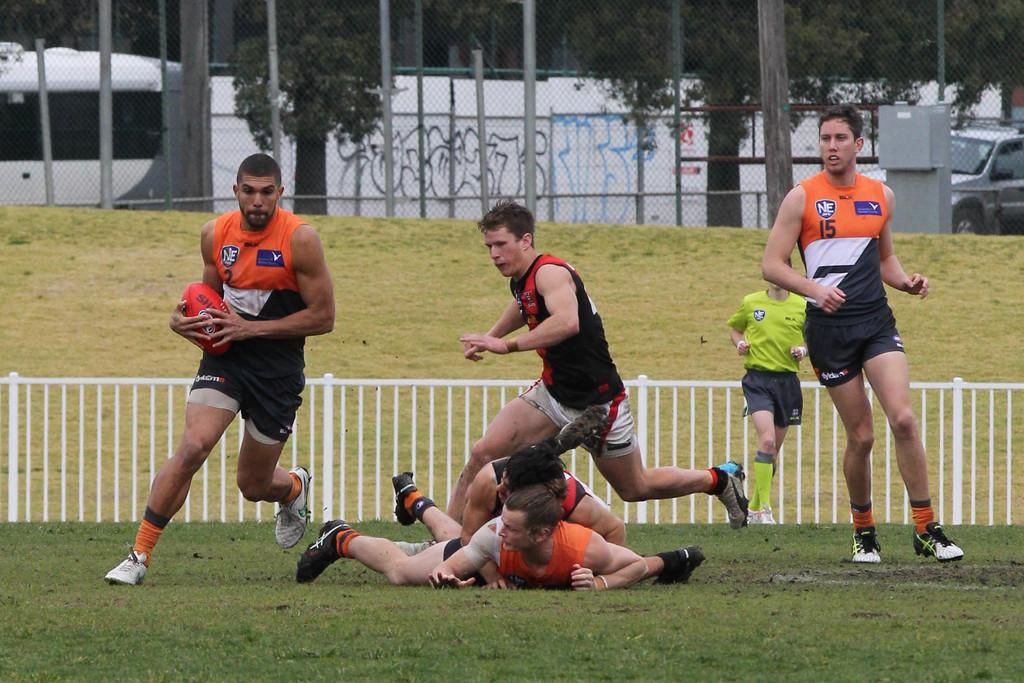<image>
Describe the image concisely. men playing a sport have orange and black uniforms with numbers like 15 on them 